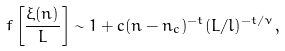<formula> <loc_0><loc_0><loc_500><loc_500>f \left [ \frac { \xi ( n ) } { L } \right ] \sim 1 + c ( n - n _ { c } ) ^ { - t } ( L / l ) ^ { - t / \nu } ,</formula> 